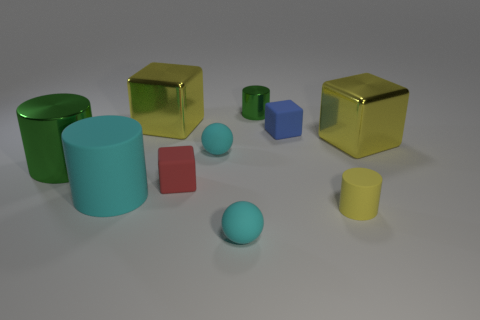What size is the yellow cylinder that is made of the same material as the blue block?
Make the answer very short. Small. There is a yellow shiny thing that is on the right side of the sphere behind the large cyan rubber object; what is its shape?
Your answer should be very brief. Cube. What number of purple things are either small matte blocks or big things?
Your answer should be very brief. 0. There is a green metal cylinder in front of the large yellow cube that is on the right side of the tiny yellow cylinder; is there a tiny rubber cube in front of it?
Provide a succinct answer. Yes. There is a shiny object that is the same color as the tiny metal cylinder; what shape is it?
Offer a terse response. Cylinder. What number of small objects are blue shiny blocks or cyan matte objects?
Offer a terse response. 2. Is the shape of the tiny red rubber object that is in front of the large shiny cylinder the same as  the blue thing?
Make the answer very short. Yes. Are there fewer cyan rubber balls than tiny cyan rubber cubes?
Your answer should be very brief. No. Is there anything else that has the same color as the large metal cylinder?
Offer a terse response. Yes. There is a large yellow thing behind the tiny blue object; what is its shape?
Make the answer very short. Cube. 